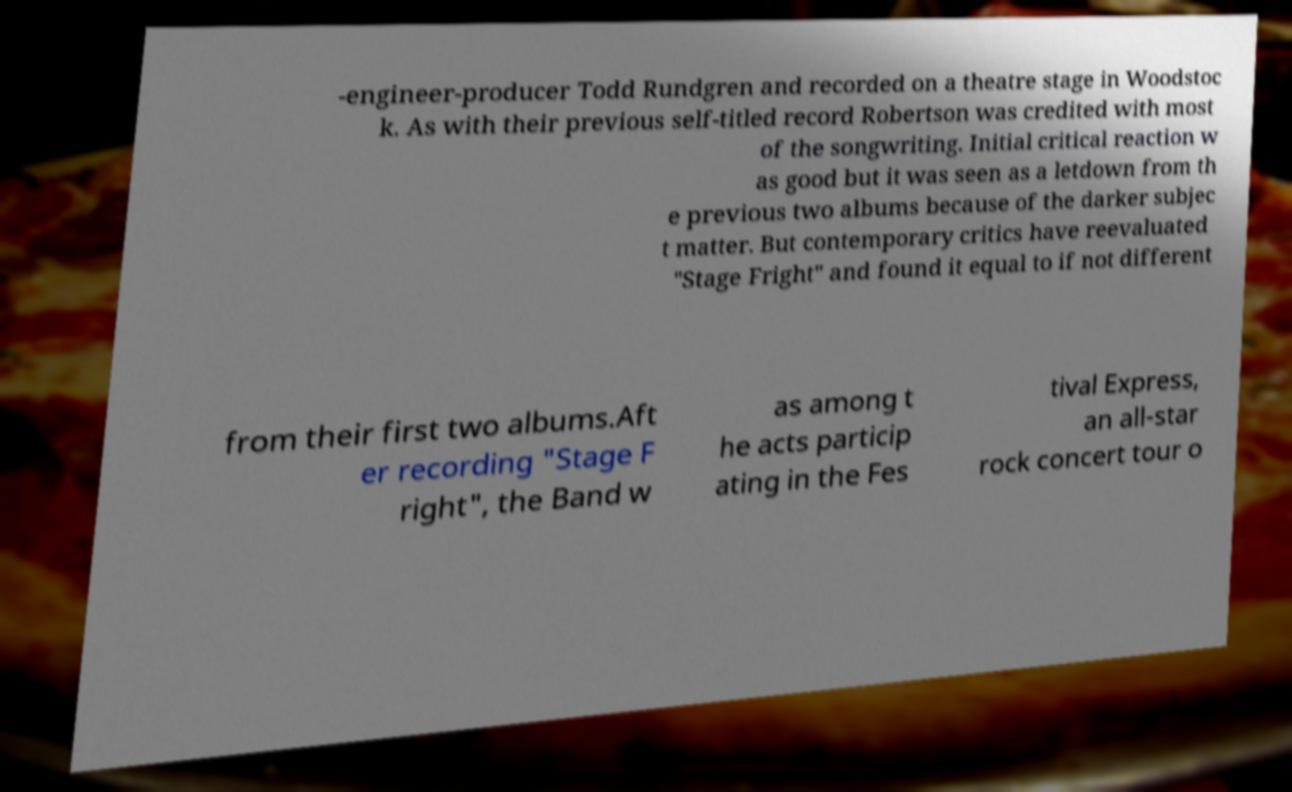For documentation purposes, I need the text within this image transcribed. Could you provide that? -engineer-producer Todd Rundgren and recorded on a theatre stage in Woodstoc k. As with their previous self-titled record Robertson was credited with most of the songwriting. Initial critical reaction w as good but it was seen as a letdown from th e previous two albums because of the darker subjec t matter. But contemporary critics have reevaluated "Stage Fright" and found it equal to if not different from their first two albums.Aft er recording "Stage F right", the Band w as among t he acts particip ating in the Fes tival Express, an all-star rock concert tour o 